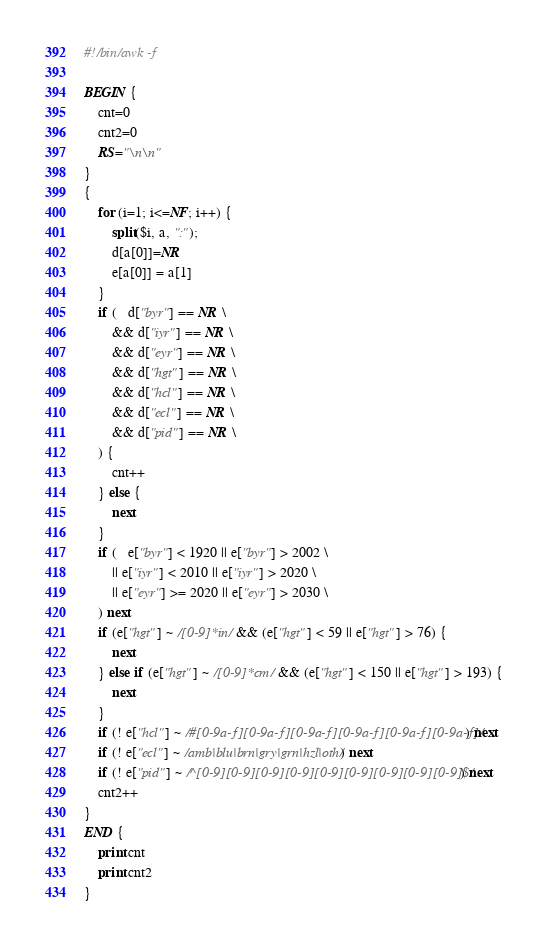Convert code to text. <code><loc_0><loc_0><loc_500><loc_500><_Awk_>#!/bin/awk -f

BEGIN {
    cnt=0
    cnt2=0
    RS="\n\n"
}
{
    for (i=1; i<=NF; i++) {
        split($i, a, ":");
        d[a[0]]=NR
        e[a[0]] = a[1]
    }
    if (   d["byr"] == NR \
        && d["iyr"] == NR \
        && d["eyr"] == NR \
        && d["hgt"] == NR \
        && d["hcl"] == NR \
        && d["ecl"] == NR \
        && d["pid"] == NR \
    ) {
        cnt++
    } else {
        next
    }
    if (   e["byr"] < 1920 || e["byr"] > 2002 \
        || e["iyr"] < 2010 || e["iyr"] > 2020 \
        || e["eyr"] >= 2020 || e["eyr"] > 2030 \
    ) next
    if (e["hgt"] ~ /[0-9]*in/ && (e["hgt"] < 59 || e["hgt"] > 76) {
        next
    } else if (e["hgt"] ~ /[0-9]*cm/ && (e["hgt"] < 150 || e["hgt"] > 193) {
        next
    }
    if (! e["hcl"] ~ /#[0-9a-f][0-9a-f][0-9a-f][0-9a-f][0-9a-f][0-9a-f]/) next
    if (! e["ecl"] ~ /amb|blu|brn|gry|grn|hzl|oth/) next
    if (! e["pid"] ~ /^[0-9][0-9][0-9][0-9][0-9][0-9][0-9][0-9][0-9]$/) next
    cnt2++
}
END {
    print cnt
    print cnt2
}

</code> 